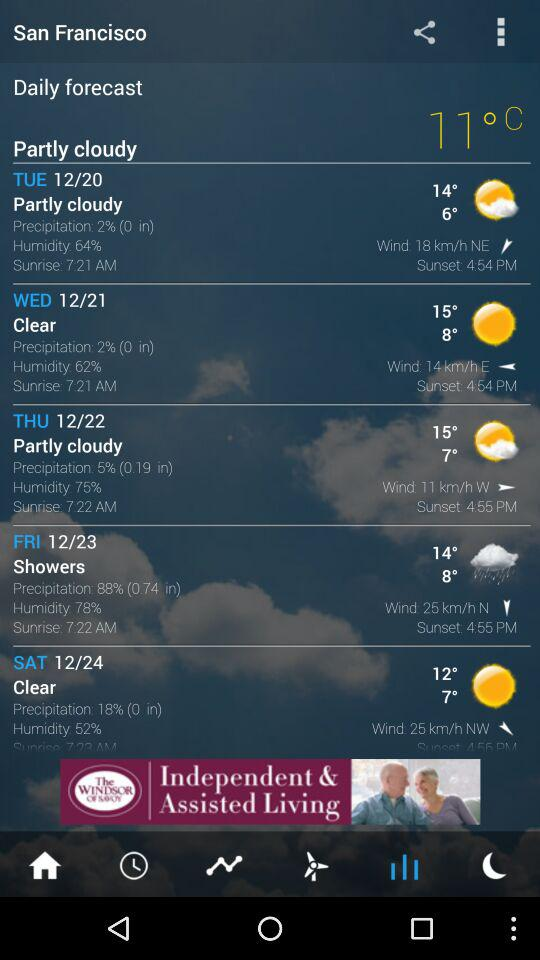How’s the weather on Thursday? The weather is partly cloudy on Thursday. 